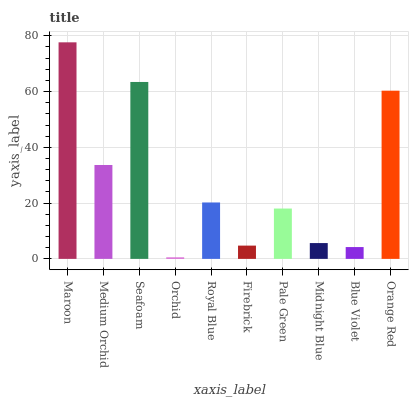Is Orchid the minimum?
Answer yes or no. Yes. Is Maroon the maximum?
Answer yes or no. Yes. Is Medium Orchid the minimum?
Answer yes or no. No. Is Medium Orchid the maximum?
Answer yes or no. No. Is Maroon greater than Medium Orchid?
Answer yes or no. Yes. Is Medium Orchid less than Maroon?
Answer yes or no. Yes. Is Medium Orchid greater than Maroon?
Answer yes or no. No. Is Maroon less than Medium Orchid?
Answer yes or no. No. Is Royal Blue the high median?
Answer yes or no. Yes. Is Pale Green the low median?
Answer yes or no. Yes. Is Midnight Blue the high median?
Answer yes or no. No. Is Maroon the low median?
Answer yes or no. No. 